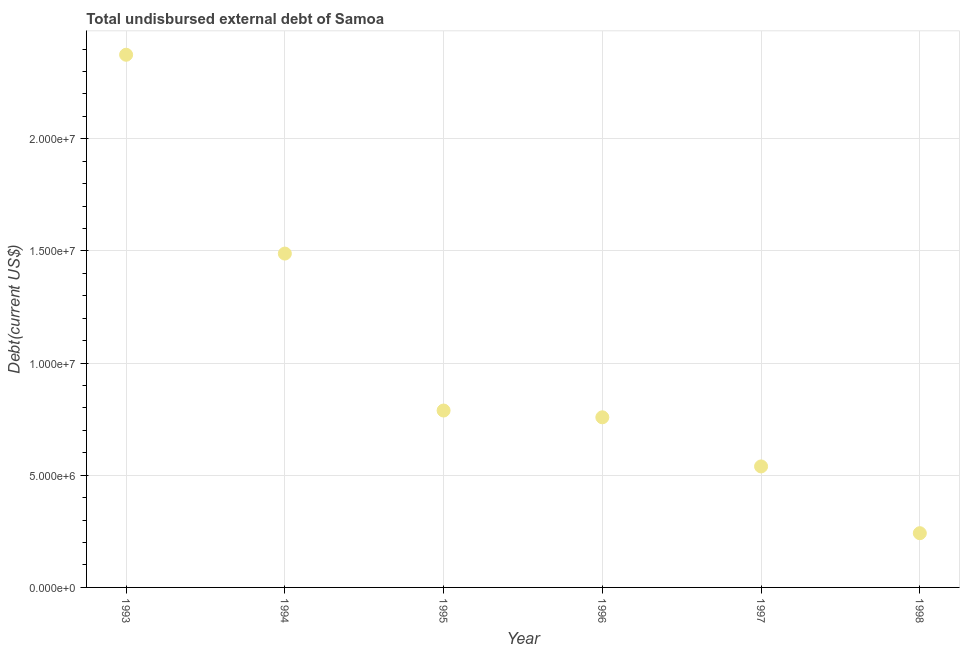What is the total debt in 1995?
Give a very brief answer. 7.89e+06. Across all years, what is the maximum total debt?
Give a very brief answer. 2.38e+07. Across all years, what is the minimum total debt?
Your answer should be very brief. 2.42e+06. What is the sum of the total debt?
Offer a very short reply. 6.19e+07. What is the difference between the total debt in 1995 and 1998?
Provide a succinct answer. 5.47e+06. What is the average total debt per year?
Keep it short and to the point. 1.03e+07. What is the median total debt?
Provide a succinct answer. 7.74e+06. What is the ratio of the total debt in 1994 to that in 1997?
Offer a very short reply. 2.76. Is the total debt in 1997 less than that in 1998?
Offer a terse response. No. Is the difference between the total debt in 1993 and 1997 greater than the difference between any two years?
Your answer should be very brief. No. What is the difference between the highest and the second highest total debt?
Offer a terse response. 8.86e+06. What is the difference between the highest and the lowest total debt?
Ensure brevity in your answer.  2.13e+07. In how many years, is the total debt greater than the average total debt taken over all years?
Provide a succinct answer. 2. Does the total debt monotonically increase over the years?
Your response must be concise. No. What is the difference between two consecutive major ticks on the Y-axis?
Ensure brevity in your answer.  5.00e+06. Does the graph contain any zero values?
Give a very brief answer. No. Does the graph contain grids?
Ensure brevity in your answer.  Yes. What is the title of the graph?
Offer a very short reply. Total undisbursed external debt of Samoa. What is the label or title of the Y-axis?
Your response must be concise. Debt(current US$). What is the Debt(current US$) in 1993?
Ensure brevity in your answer.  2.38e+07. What is the Debt(current US$) in 1994?
Make the answer very short. 1.49e+07. What is the Debt(current US$) in 1995?
Your answer should be compact. 7.89e+06. What is the Debt(current US$) in 1996?
Your answer should be very brief. 7.58e+06. What is the Debt(current US$) in 1997?
Offer a very short reply. 5.40e+06. What is the Debt(current US$) in 1998?
Make the answer very short. 2.42e+06. What is the difference between the Debt(current US$) in 1993 and 1994?
Your answer should be compact. 8.86e+06. What is the difference between the Debt(current US$) in 1993 and 1995?
Provide a succinct answer. 1.59e+07. What is the difference between the Debt(current US$) in 1993 and 1996?
Your answer should be very brief. 1.62e+07. What is the difference between the Debt(current US$) in 1993 and 1997?
Your answer should be compact. 1.84e+07. What is the difference between the Debt(current US$) in 1993 and 1998?
Ensure brevity in your answer.  2.13e+07. What is the difference between the Debt(current US$) in 1994 and 1995?
Your answer should be very brief. 7.00e+06. What is the difference between the Debt(current US$) in 1994 and 1996?
Offer a terse response. 7.30e+06. What is the difference between the Debt(current US$) in 1994 and 1997?
Ensure brevity in your answer.  9.49e+06. What is the difference between the Debt(current US$) in 1994 and 1998?
Ensure brevity in your answer.  1.25e+07. What is the difference between the Debt(current US$) in 1995 and 1996?
Keep it short and to the point. 3.02e+05. What is the difference between the Debt(current US$) in 1995 and 1997?
Give a very brief answer. 2.49e+06. What is the difference between the Debt(current US$) in 1995 and 1998?
Offer a terse response. 5.47e+06. What is the difference between the Debt(current US$) in 1996 and 1997?
Offer a very short reply. 2.19e+06. What is the difference between the Debt(current US$) in 1996 and 1998?
Your answer should be very brief. 5.17e+06. What is the difference between the Debt(current US$) in 1997 and 1998?
Provide a short and direct response. 2.98e+06. What is the ratio of the Debt(current US$) in 1993 to that in 1994?
Offer a terse response. 1.6. What is the ratio of the Debt(current US$) in 1993 to that in 1995?
Make the answer very short. 3.01. What is the ratio of the Debt(current US$) in 1993 to that in 1996?
Provide a short and direct response. 3.13. What is the ratio of the Debt(current US$) in 1993 to that in 1997?
Your response must be concise. 4.4. What is the ratio of the Debt(current US$) in 1993 to that in 1998?
Your answer should be very brief. 9.82. What is the ratio of the Debt(current US$) in 1994 to that in 1995?
Your response must be concise. 1.89. What is the ratio of the Debt(current US$) in 1994 to that in 1996?
Provide a succinct answer. 1.96. What is the ratio of the Debt(current US$) in 1994 to that in 1997?
Your response must be concise. 2.76. What is the ratio of the Debt(current US$) in 1994 to that in 1998?
Give a very brief answer. 6.16. What is the ratio of the Debt(current US$) in 1995 to that in 1997?
Offer a terse response. 1.46. What is the ratio of the Debt(current US$) in 1995 to that in 1998?
Your response must be concise. 3.26. What is the ratio of the Debt(current US$) in 1996 to that in 1997?
Your answer should be very brief. 1.41. What is the ratio of the Debt(current US$) in 1996 to that in 1998?
Provide a succinct answer. 3.14. What is the ratio of the Debt(current US$) in 1997 to that in 1998?
Your answer should be compact. 2.23. 